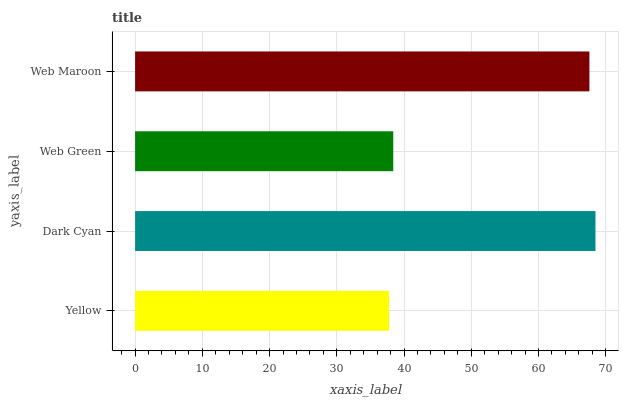Is Yellow the minimum?
Answer yes or no. Yes. Is Dark Cyan the maximum?
Answer yes or no. Yes. Is Web Green the minimum?
Answer yes or no. No. Is Web Green the maximum?
Answer yes or no. No. Is Dark Cyan greater than Web Green?
Answer yes or no. Yes. Is Web Green less than Dark Cyan?
Answer yes or no. Yes. Is Web Green greater than Dark Cyan?
Answer yes or no. No. Is Dark Cyan less than Web Green?
Answer yes or no. No. Is Web Maroon the high median?
Answer yes or no. Yes. Is Web Green the low median?
Answer yes or no. Yes. Is Web Green the high median?
Answer yes or no. No. Is Yellow the low median?
Answer yes or no. No. 